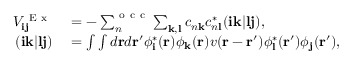<formula> <loc_0><loc_0><loc_500><loc_500>\begin{array} { r l } { V _ { i j } ^ { E x } } & = - \sum _ { n } ^ { o c c } \sum _ { k , l } c _ { n k } c _ { n l } ^ { * } ( i k | l j ) , } \\ { ( i k | l j ) } & = \int \int d r d r ^ { \prime } \phi _ { i } ^ { * } ( r ) \phi _ { k } ( r ) v ( r - r ^ { \prime } ) \phi _ { l } ^ { * } ( r ^ { \prime } ) \phi _ { j } ( r ^ { \prime } ) , } \end{array}</formula> 